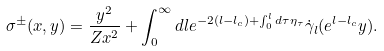<formula> <loc_0><loc_0><loc_500><loc_500>\sigma ^ { \pm } ( x , y ) = \frac { y ^ { 2 } } { Z x ^ { 2 } } + \int _ { 0 } ^ { \infty } d l e ^ { - 2 ( l - l _ { c } ) + \int _ { 0 } ^ { l } d \tau \eta _ { \tau } } \dot { \gamma } _ { l } ( e ^ { l - l _ { c } } y ) .</formula> 